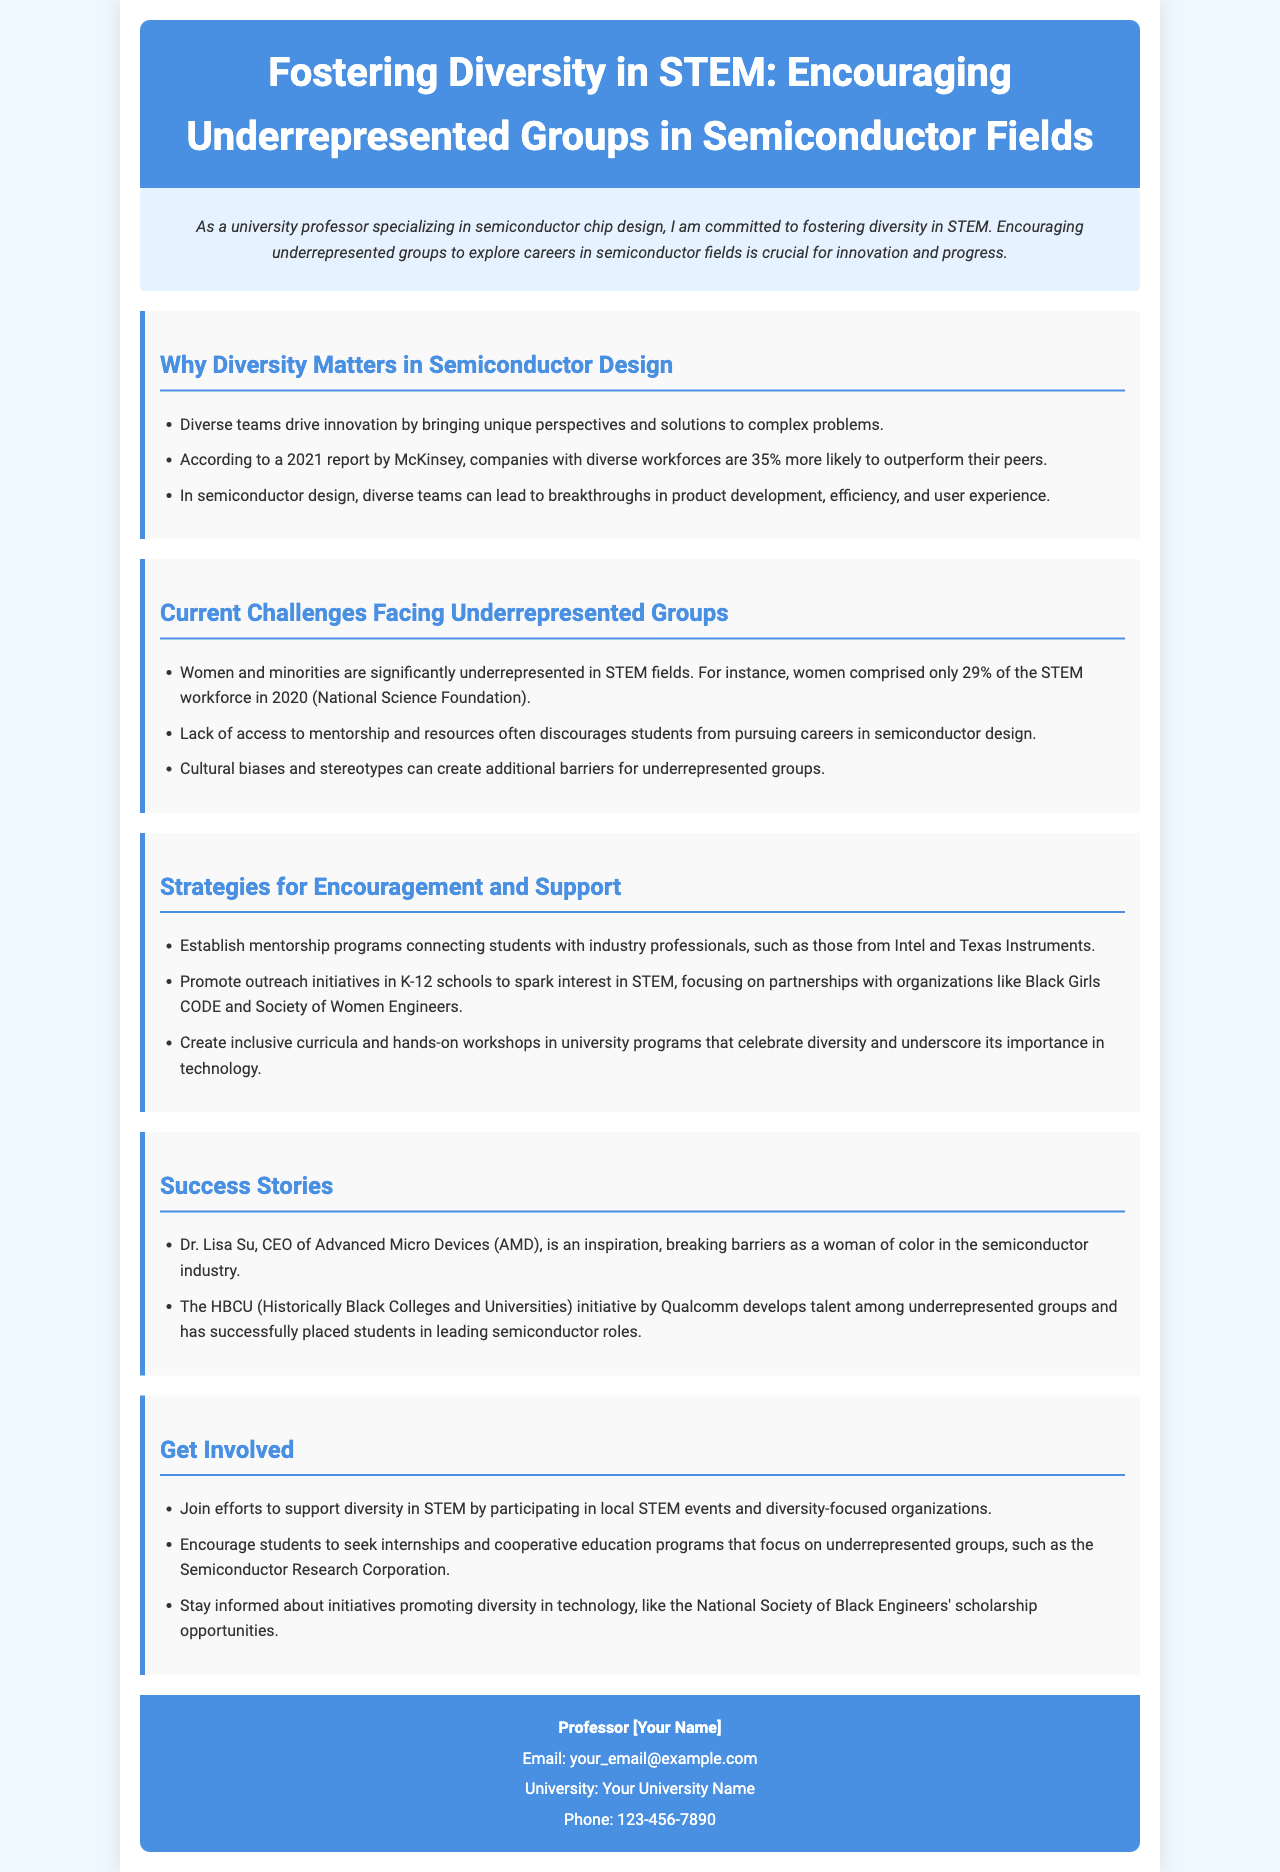What is the main focus of the brochure? The brochure's main focus is to foster diversity in STEM and encourage underrepresented groups in semiconductor fields.
Answer: Fostering diversity in STEM What percentage of the STEM workforce did women comprise in 2020? The document states that women comprised only 29% of the STEM workforce in 2020.
Answer: 29% Which company is mentioned as part of mentorship programs? The document mentions Intel and Texas Instruments as companies involved in mentorship programs.
Answer: Intel and Texas Instruments What initiative develops talent among underrepresented groups specifically mentioned in the document? The HBCU initiative by Qualcomm is highlighted as developing talent among underrepresented groups.
Answer: HBCU initiative by Qualcomm According to the document, how much more likely are diverse companies to outperform their peers? The document cites that companies with diverse workforces are 35% more likely to outperform their peers.
Answer: 35% What are K-12 outreach initiatives supposed to promote according to the brochure? K-12 outreach initiatives are intended to spark interest in STEM.
Answer: Spark interest in STEM Who is cited as an inspiration for breaking barriers in the semiconductor industry? Dr. Lisa Su, CEO of Advanced Micro Devices (AMD), is cited as an inspiration.
Answer: Dr. Lisa Su What is one of the strategies mentioned to support diversity in technology? One strategy mentioned is to encourage students to seek internships and cooperative education programs.
Answer: Seek internships and cooperative education programs 